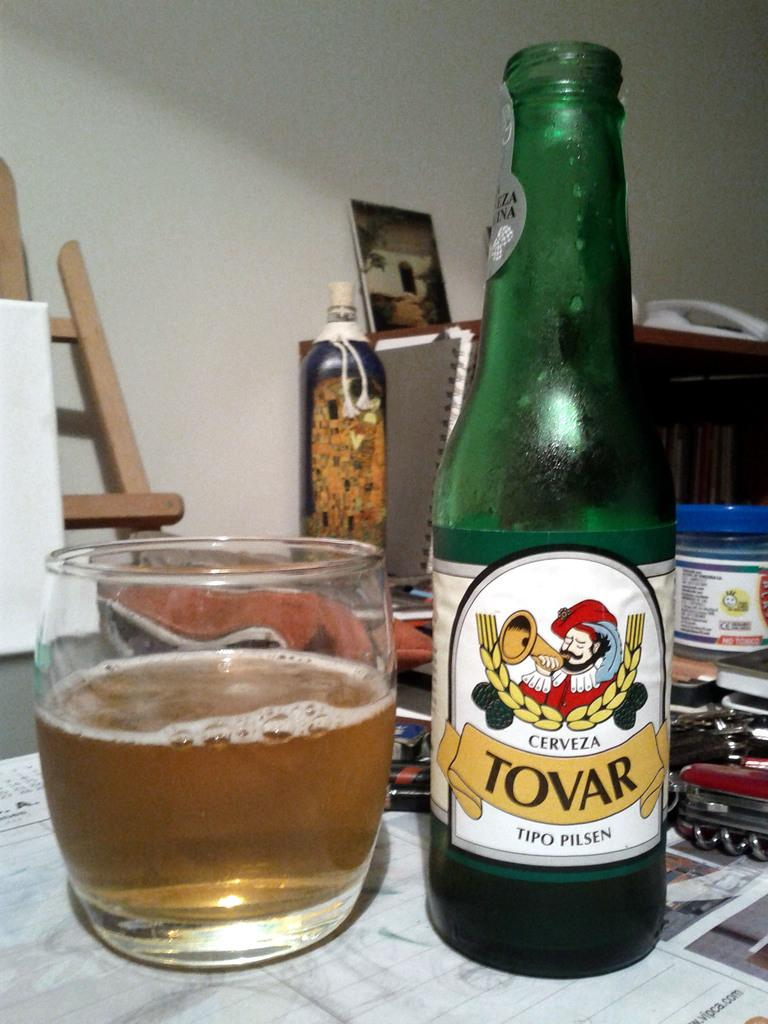<image>
Relay a brief, clear account of the picture shown. A botle of Tovar Cerveza sits next to a freshly poured glass. 